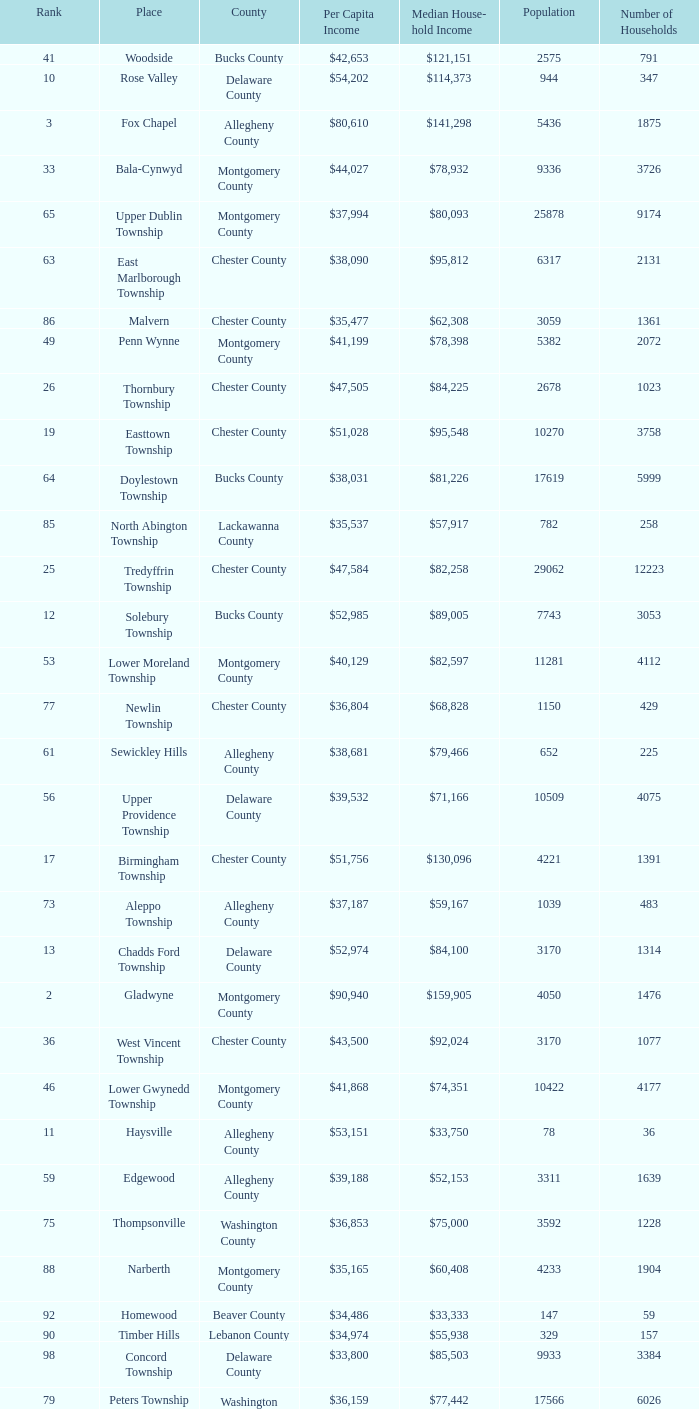What is the per capita income for Fayette County? $42,131. 